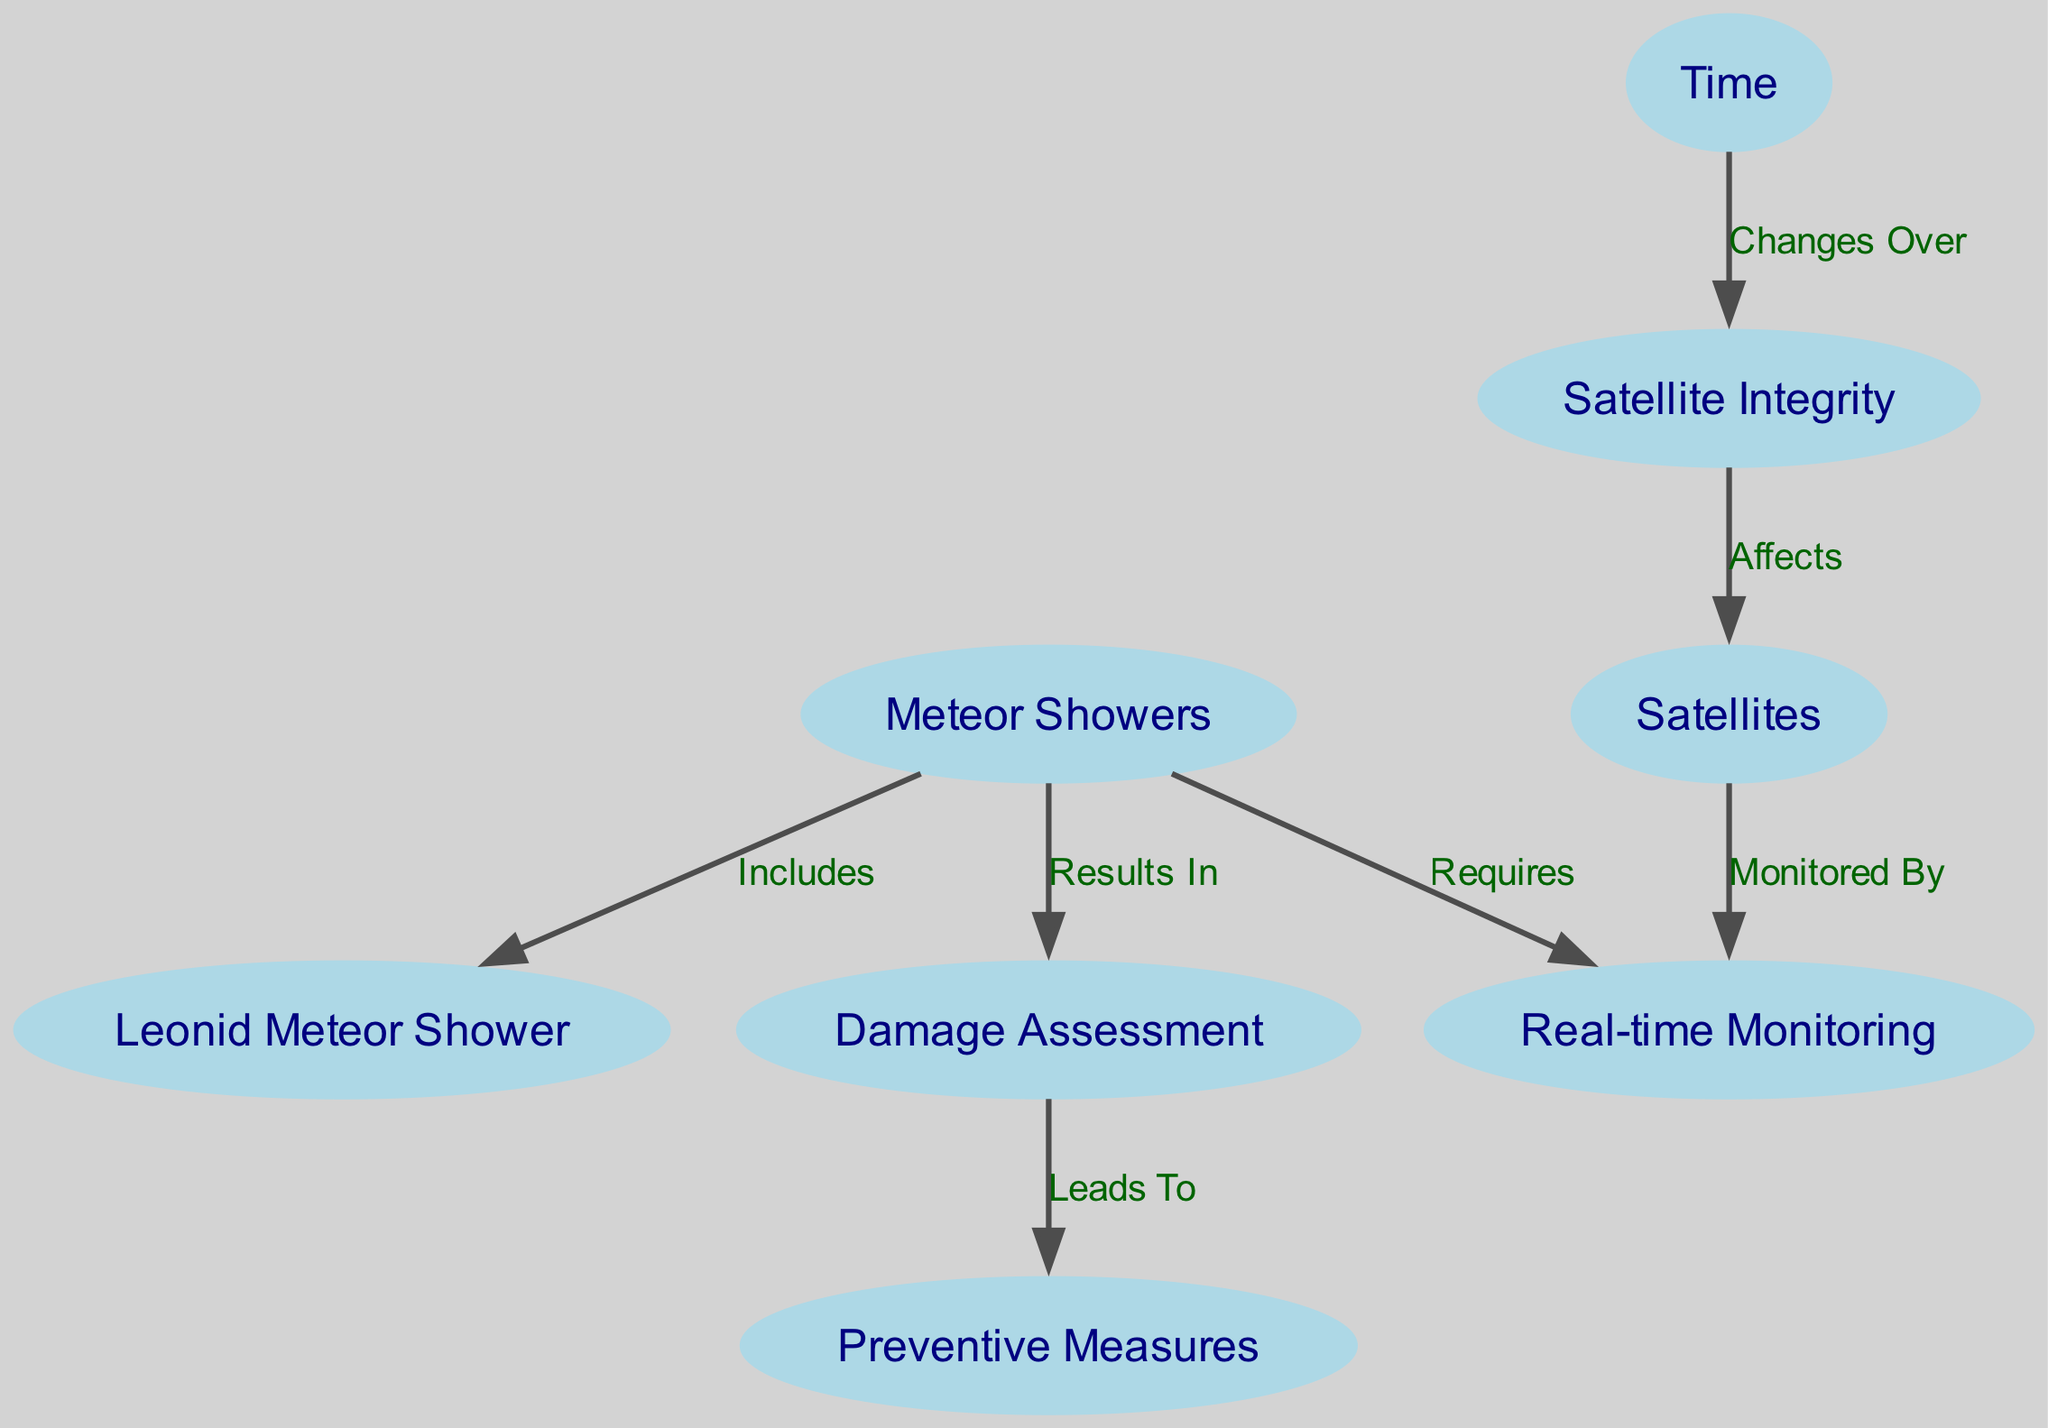What are the primary nodes in the diagram? The primary nodes in the diagram include Meteor Showers, Satellite Integrity, Time, Leonid Meteor Shower, Satellites, Damage Assessment, Preventive Measures, and Real-time Monitoring. These represent the key elements of the study depicted in the diagram.
Answer: Meteor Showers, Satellite Integrity, Time, Leonid Meteor Shower, Satellites, Damage Assessment, Preventive Measures, Real-time Monitoring How many edges are there in the diagram? By reviewing the connections (edges) in the diagram, we can count a total of 7 edges that connect various pairs of nodes, reflecting the relationships between the phenomena depicted.
Answer: 7 What relationship does Satellite Integrity have with Satellites? The edge from Satellite Integrity to Satellites is labeled "Affects," indicating that the condition of Satellite Integrity impacts or influences the functionality and operation of Satellites.
Answer: Affects Which meteor shower is specified in the diagram? The diagram specifically includes the Leonid Meteor Shower as a notable instance of meteor showers, highlighting its relevance to the overall context of the research.
Answer: Leonid Meteor Shower What leads to Preventive Measures according to the diagram? The edge indicating a relationship from Damage Assessment to Preventive Measures shows that after evaluating the damage caused by meteor showers, there is a need to take actions that mitigate future impacts, thus leading to preventive measures.
Answer: Damage Assessment How are meteor showers monitored in real-time? The edge from Satellites to Real-time Monitoring signifies that the integrity of satellites is continuously observed or monitored as events like meteor showers occur, establishing a direct relationship for oversight.
Answer: Real-time Monitoring What is required for monitoring meteor showers? The edge labeled "Requires" from Meteor Showers to Real-time Monitoring indicates that to effectively track the effects of meteor showers on satellites, continuous observation or monitoring of the satellite conditions is necessary.
Answer: Real-time Monitoring What does damage assessment result from? The connection marked "Results In" shows that meteor showers cause damage that necessitates an assessment, which indicates the evaluation of the impact on satellite integrity stems from the occurrence of meteor showers.
Answer: Meteor Showers 